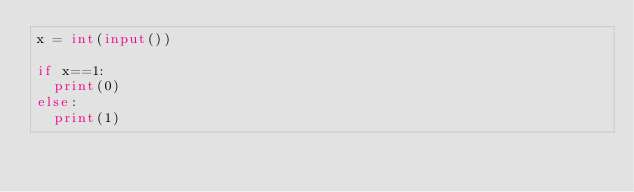<code> <loc_0><loc_0><loc_500><loc_500><_Python_>x = int(input())

if x==1:
  print(0)
else:
  print(1)</code> 